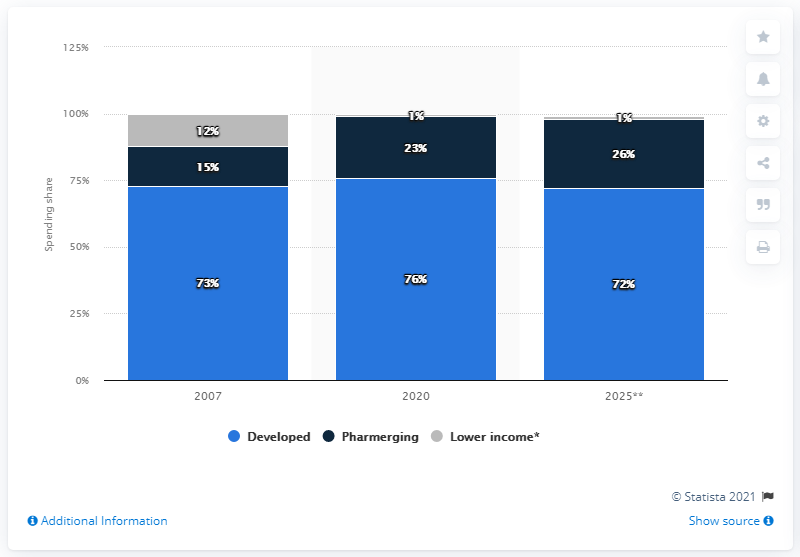Highlight a few significant elements in this photo. According to projections, developed countries are expected to hold 72% of global medicine spending in 2025. In 2007, global medicine spending began to be distributed in a certain way. 